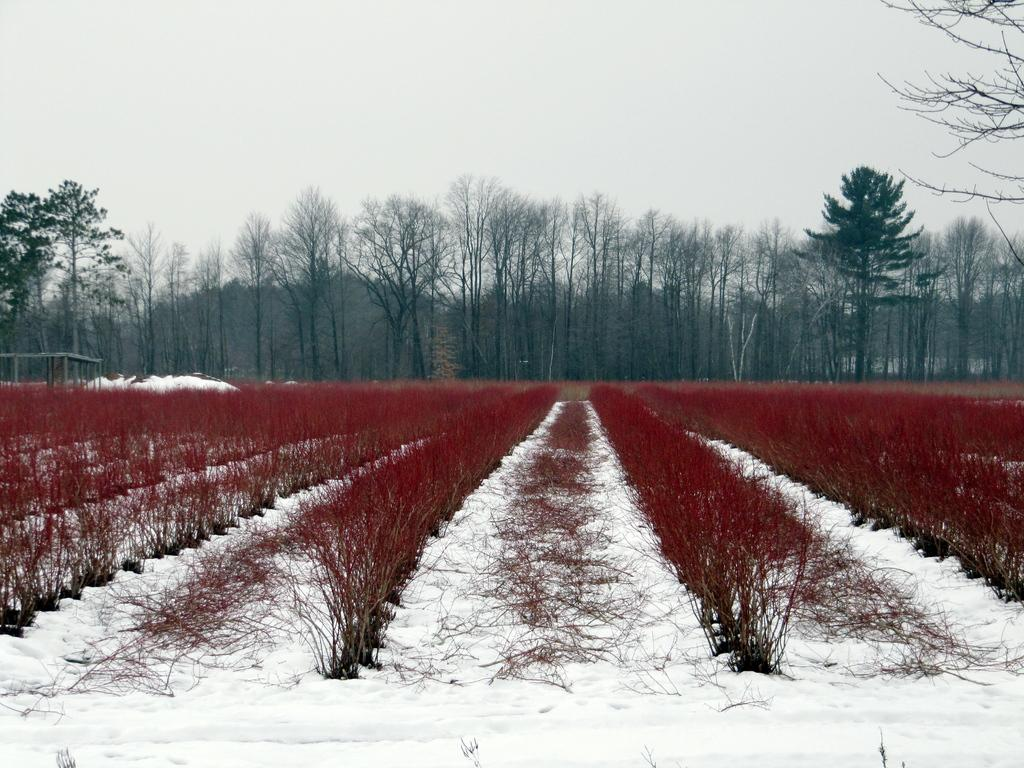What is the predominant weather condition in the image? There is snow in the image, indicating a cold and wintry condition. What color are the pants worn by the person in the image? The pants in the image are red. What can be seen in the distance in the image? There are trees in the background of the image. How would you describe the sky in the image? The sky is clear in the background of the image. What type of toothpaste is being used to paint the trees in the image? There is no toothpaste or painting activity present in the image; it features snow, red pants, trees, and a clear sky. 